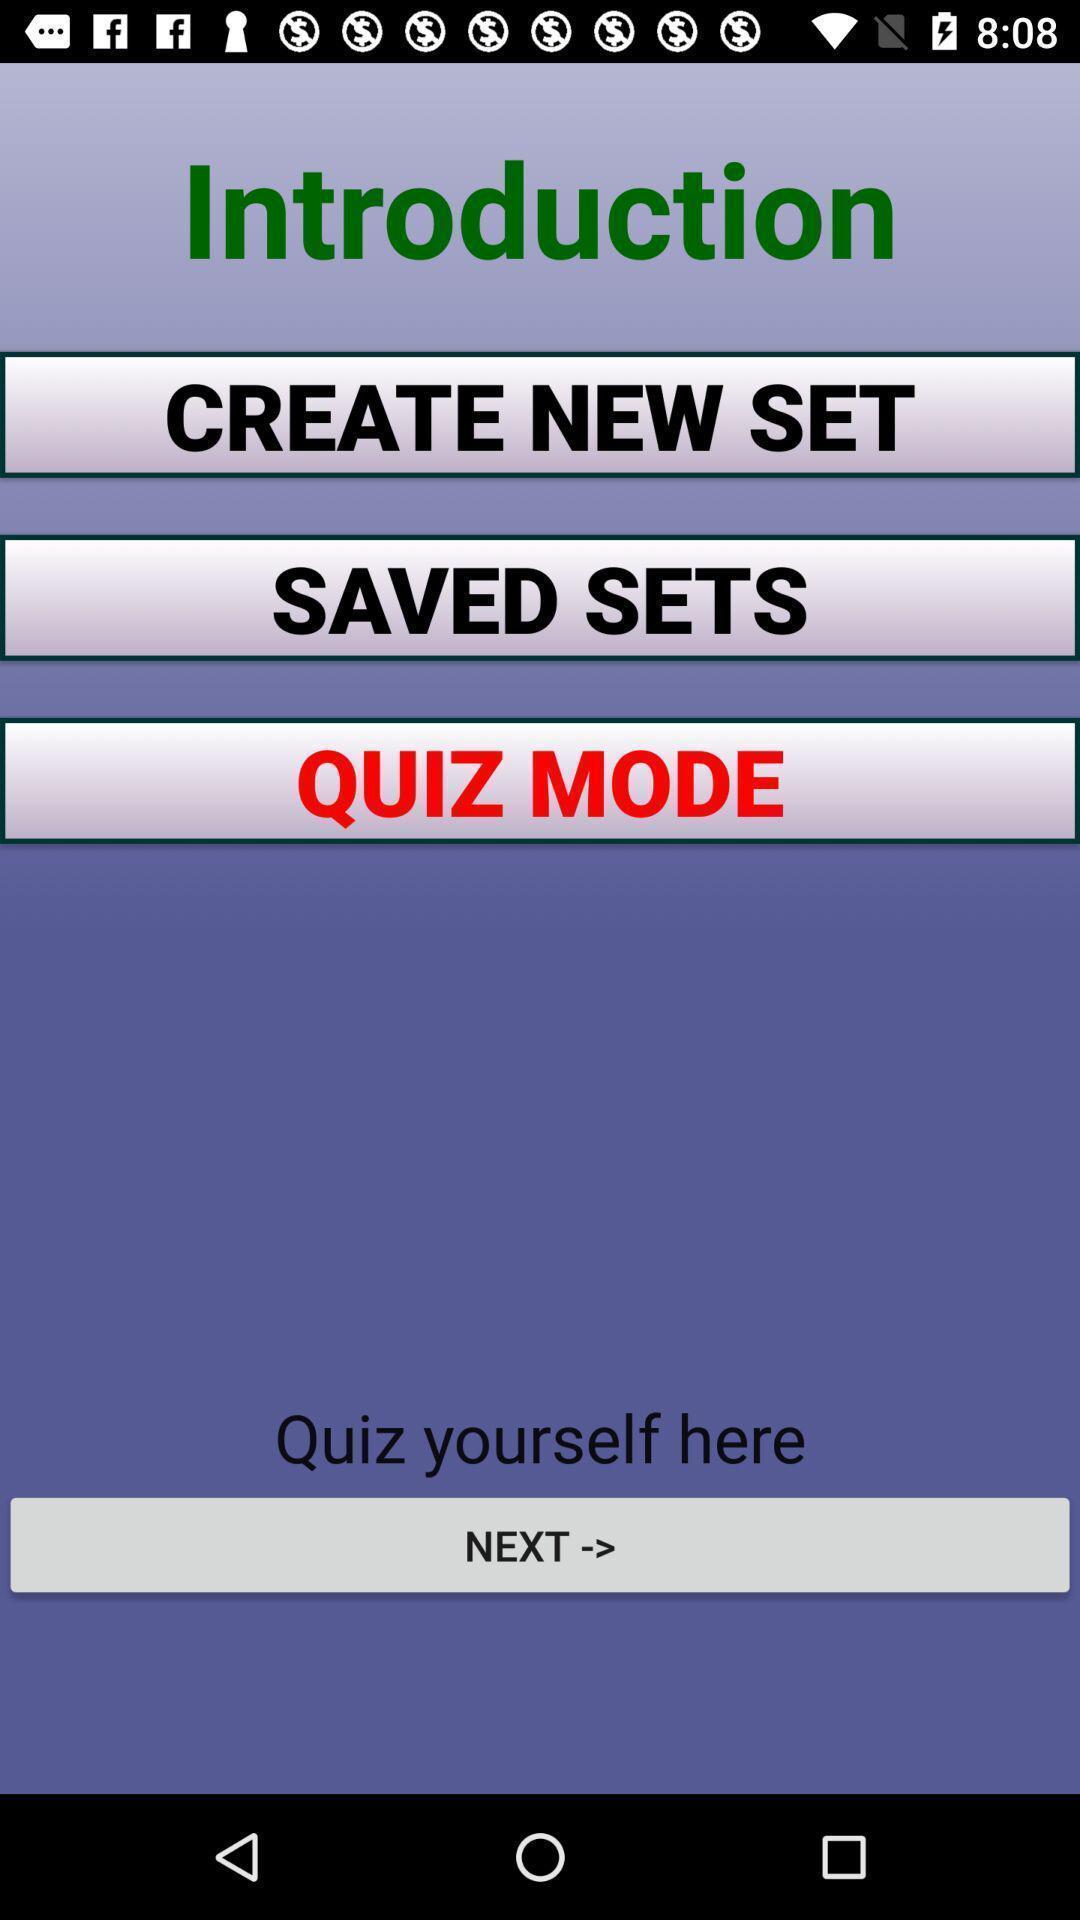What is the overall content of this screenshot? Screen displaying introduction to create. 